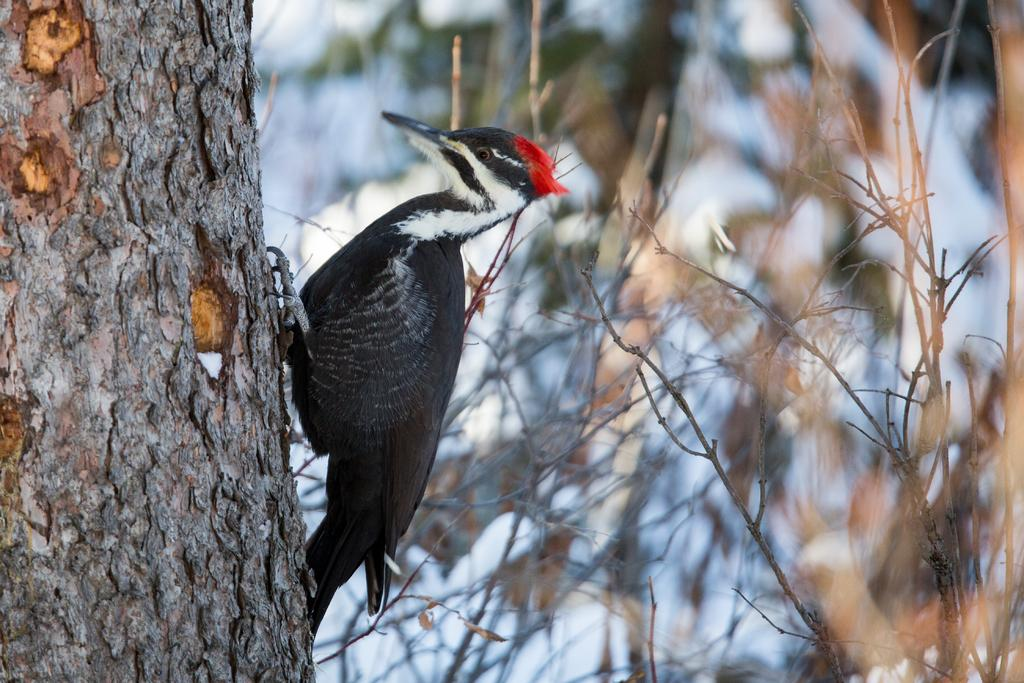What type of animal is sitting on the tree in the image? There is a bird sitting on a tree in the image. Where is the tree located in the image? The tree is on the left side of the image. What else can be seen on the right side of the image? There are plants on the right side of the image. What type of skirt is the bird wearing in the image? There is no skirt present in the image, as birds do not wear clothing. 